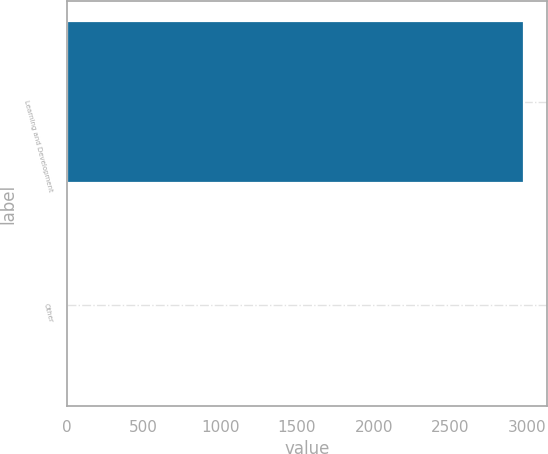<chart> <loc_0><loc_0><loc_500><loc_500><bar_chart><fcel>Learning and Development<fcel>Other<nl><fcel>2981.6<fcel>3.5<nl></chart> 